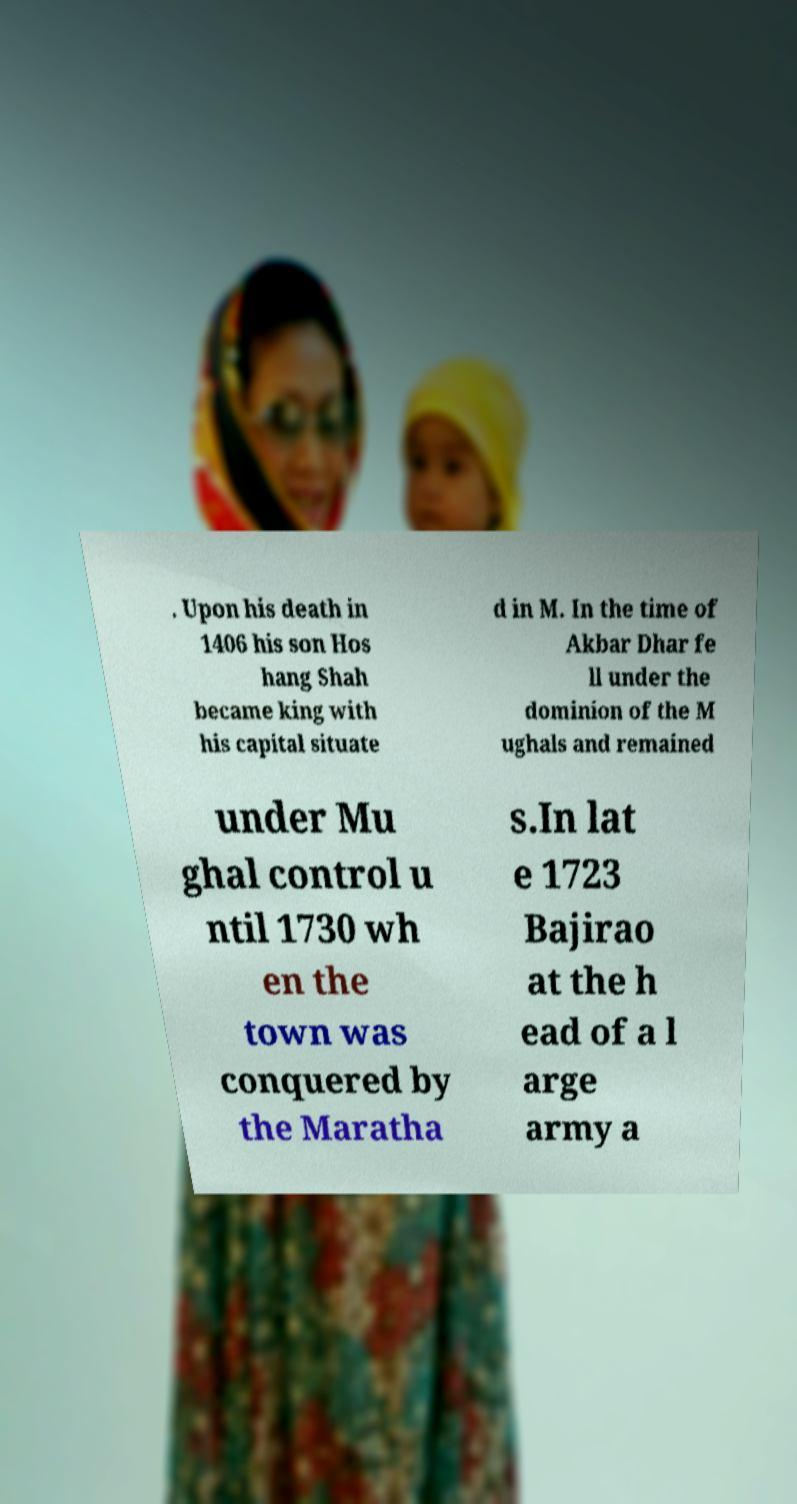Can you read and provide the text displayed in the image?This photo seems to have some interesting text. Can you extract and type it out for me? . Upon his death in 1406 his son Hos hang Shah became king with his capital situate d in M. In the time of Akbar Dhar fe ll under the dominion of the M ughals and remained under Mu ghal control u ntil 1730 wh en the town was conquered by the Maratha s.In lat e 1723 Bajirao at the h ead of a l arge army a 